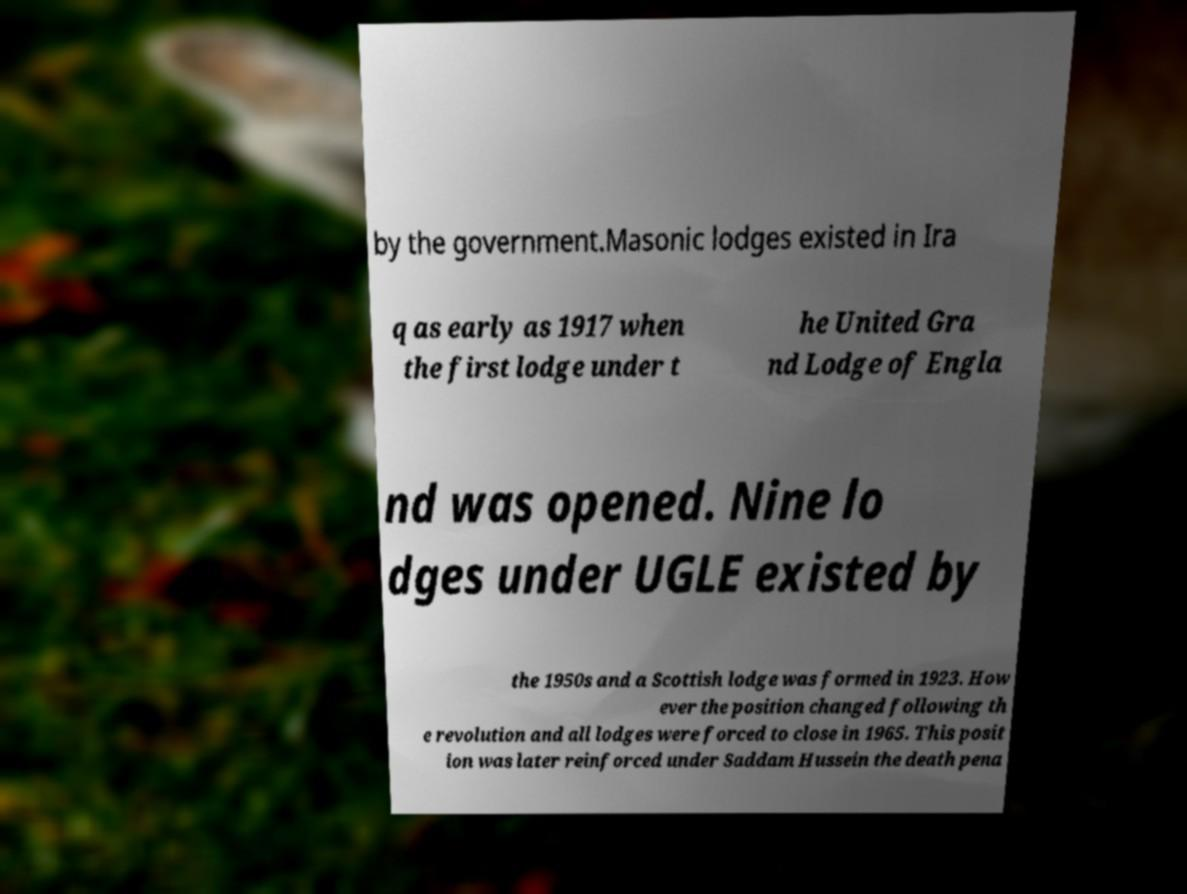Could you extract and type out the text from this image? by the government.Masonic lodges existed in Ira q as early as 1917 when the first lodge under t he United Gra nd Lodge of Engla nd was opened. Nine lo dges under UGLE existed by the 1950s and a Scottish lodge was formed in 1923. How ever the position changed following th e revolution and all lodges were forced to close in 1965. This posit ion was later reinforced under Saddam Hussein the death pena 